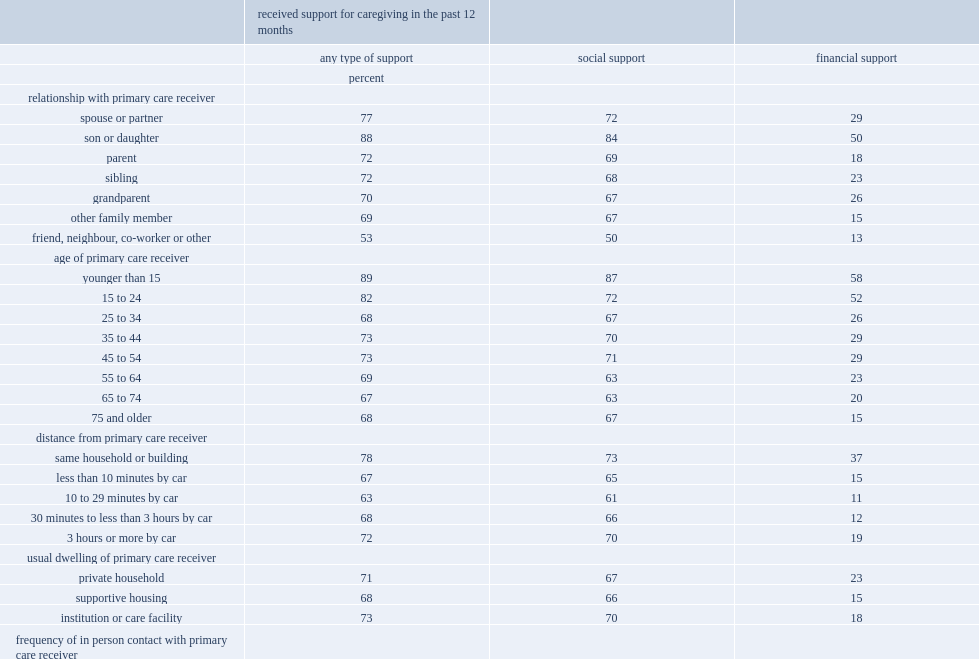Among those who lived with their primary care receivers, what was the percent reported receiving some form of financial support? 37.0. Among those who lived with their primary care receivers, what was the percent of those who lived less than 10 minutes away by car? 15.0. Among those who lived with their primary care receivers, what was the percent of those who lived between 10 and 29 minutes away by car? 11.0. What was the percent of caregivers who visited their primary care receiver less than once a month reported receiving some form of support? 59.0. What was the figure among those who reported daily visits? 73.0. Parse the table in full. {'header': ['', 'received support for caregiving in the past 12 months', '', ''], 'rows': [['', 'any type of support', 'social support', 'financial support'], ['', 'percent', '', ''], ['relationship with primary care receiver', '', '', ''], ['spouse or partner', '77', '72', '29'], ['son or daughter', '88', '84', '50'], ['parent', '72', '69', '18'], ['sibling', '72', '68', '23'], ['grandparent', '70', '67', '26'], ['other family member', '69', '67', '15'], ['friend, neighbour, co-worker or other', '53', '50', '13'], ['age of primary care receiver', '', '', ''], ['younger than 15', '89', '87', '58'], ['15 to 24', '82', '72', '52'], ['25 to 34', '68', '67', '26'], ['35 to 44', '73', '70', '29'], ['45 to 54', '73', '71', '29'], ['55 to 64', '69', '63', '23'], ['65 to 74', '67', '63', '20'], ['75 and older', '68', '67', '15'], ['distance from primary care receiver', '', '', ''], ['same household or building', '78', '73', '37'], ['less than 10 minutes by car', '67', '65', '15'], ['10 to 29 minutes by car', '63', '61', '11'], ['30 minutes to less than 3 hours by car', '68', '66', '12'], ['3 hours or more by car', '72', '70', '19'], ['usual dwelling of primary care receiver', '', '', ''], ['private household', '71', '67', '23'], ['supportive housing', '68', '66', '15'], ['institution or care facility', '73', '70', '18'], ['frequency of in person contact with primary care receiver', '', '', ''], ['less than once a month', '59', '58', '13'], ['at least once a month', '61', '59', '11'], ['at least once a week', '66', '64', '12'], ['daily', '73', '70', '22'], ['lives with care receiver', '80', '75', '38']]} 